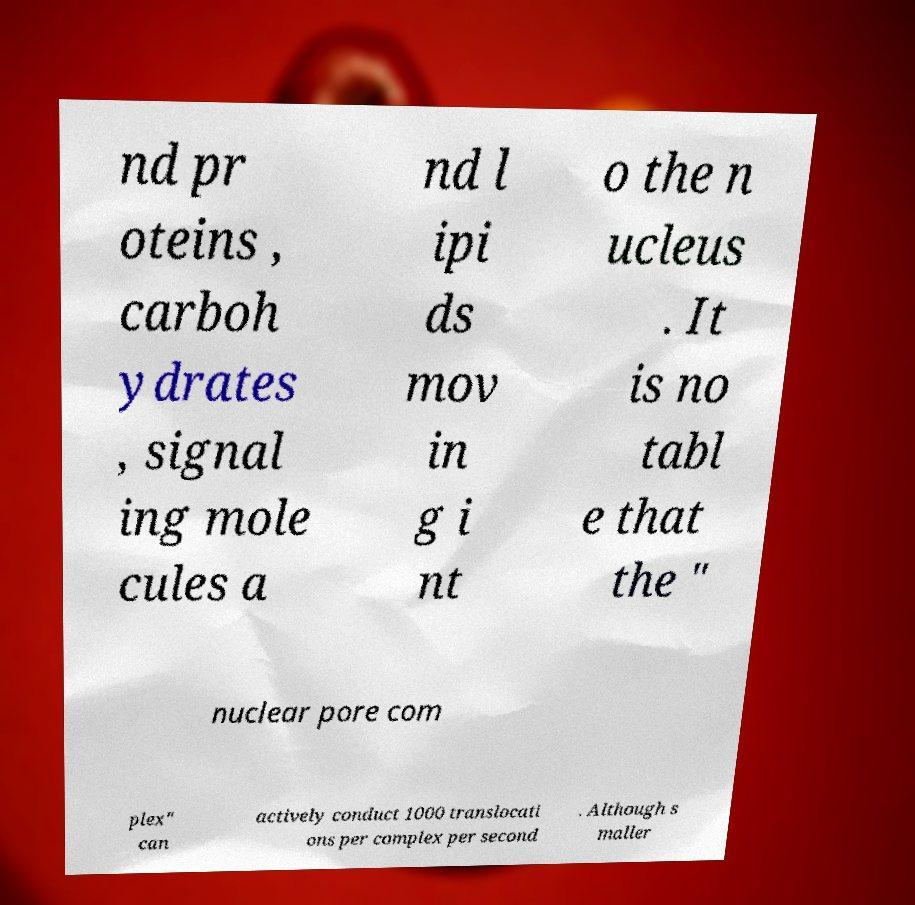Could you assist in decoding the text presented in this image and type it out clearly? nd pr oteins , carboh ydrates , signal ing mole cules a nd l ipi ds mov in g i nt o the n ucleus . It is no tabl e that the " nuclear pore com plex" can actively conduct 1000 translocati ons per complex per second . Although s maller 